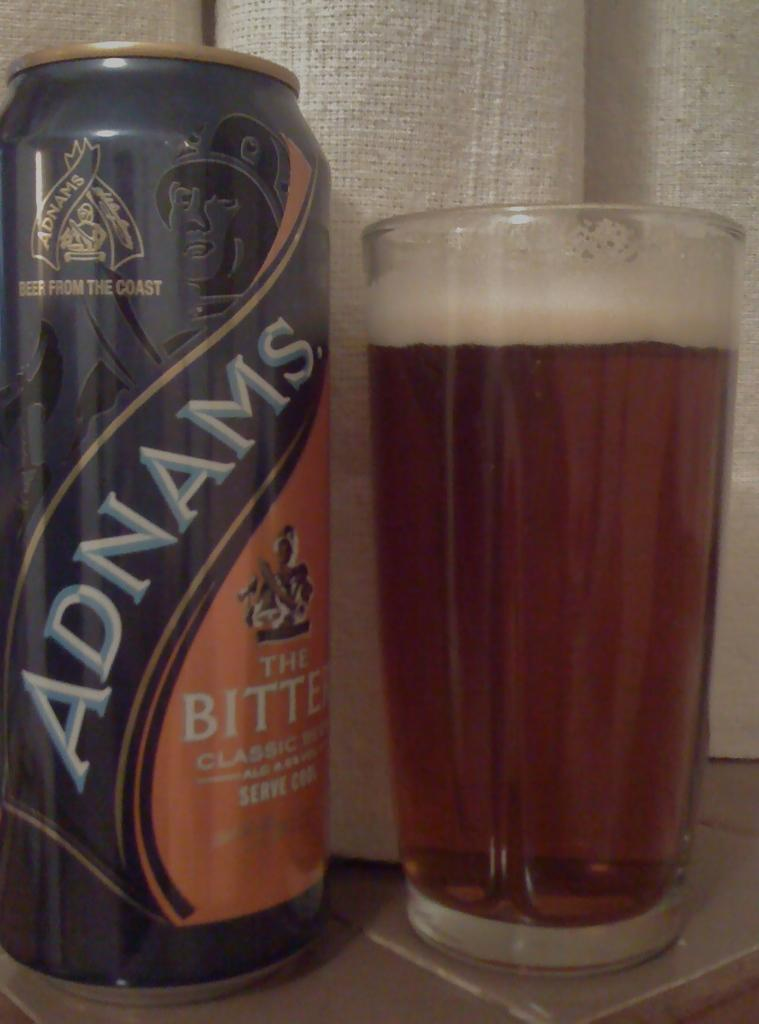<image>
Relay a brief, clear account of the picture shown. A can of Adnams sits next to a full glass. 